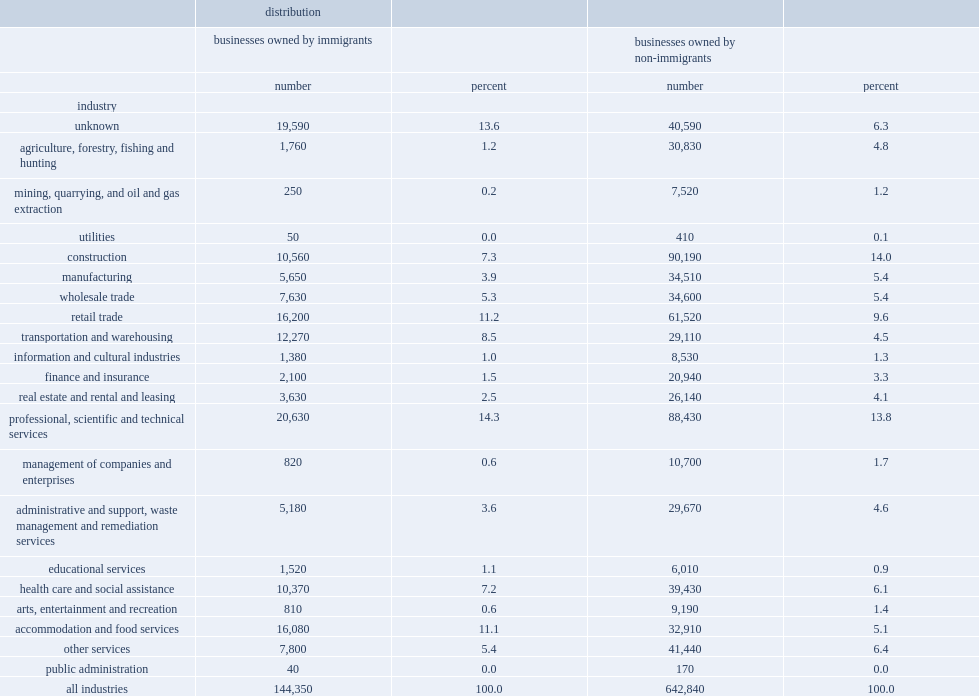Which single group has the largest percent? Professional, scientific and technical services. 